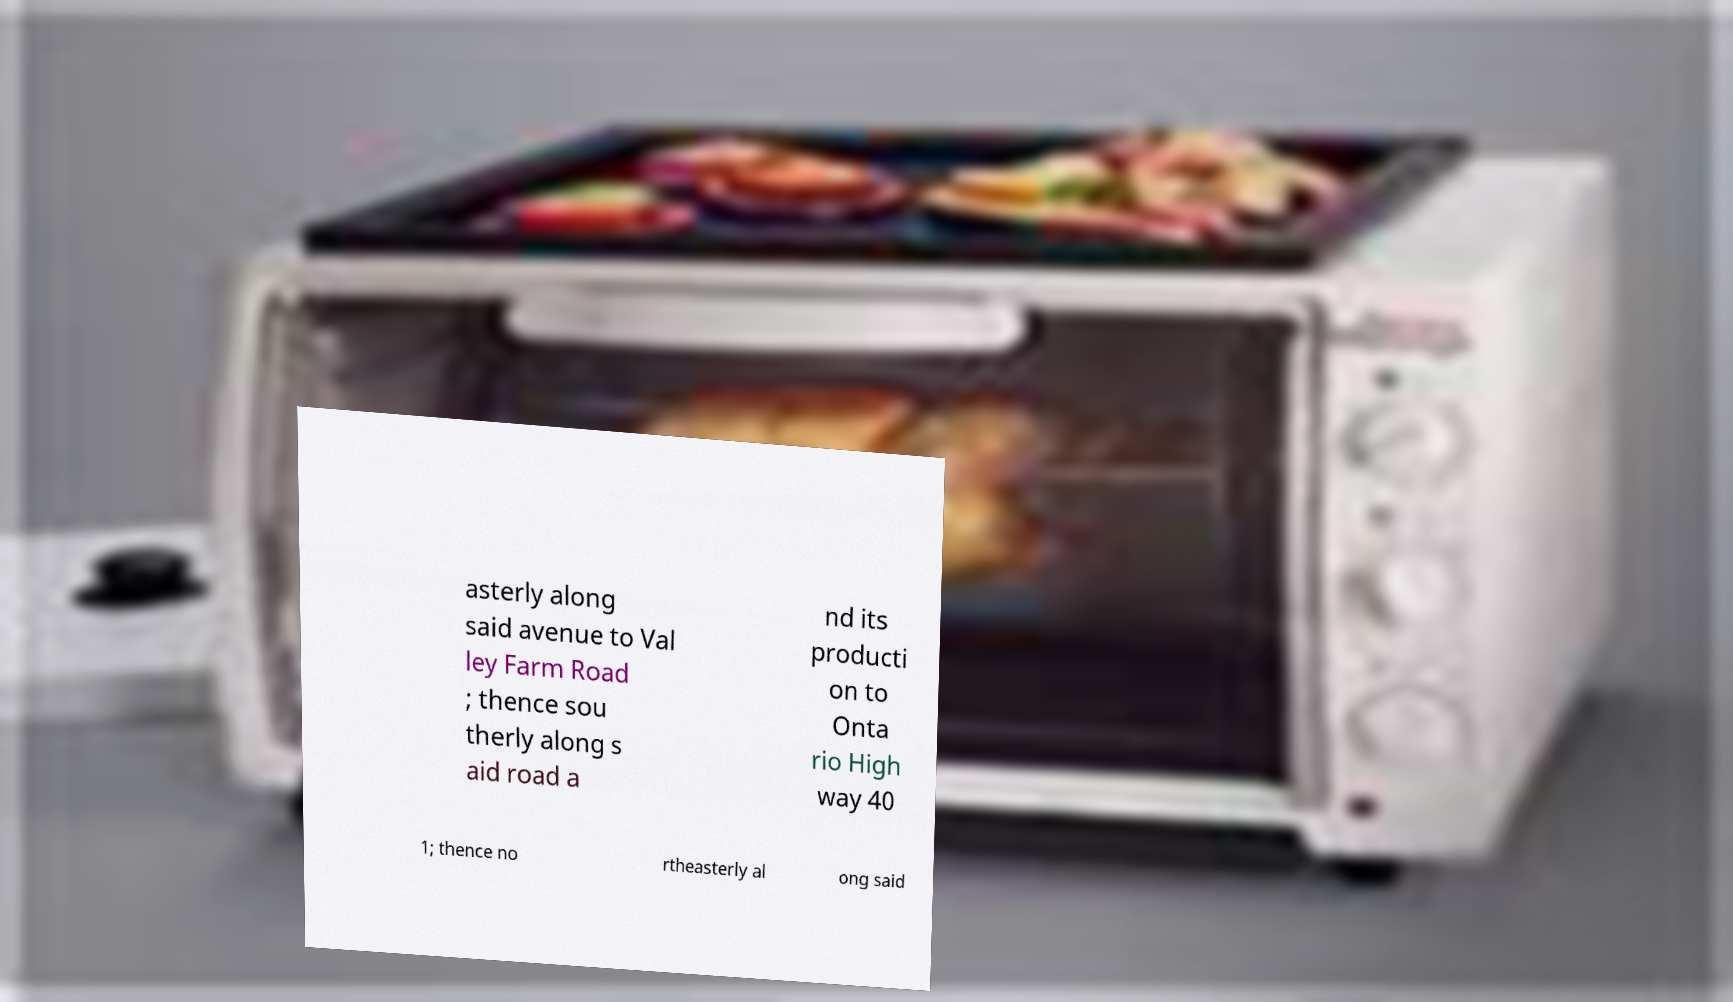What messages or text are displayed in this image? I need them in a readable, typed format. asterly along said avenue to Val ley Farm Road ; thence sou therly along s aid road a nd its producti on to Onta rio High way 40 1; thence no rtheasterly al ong said 